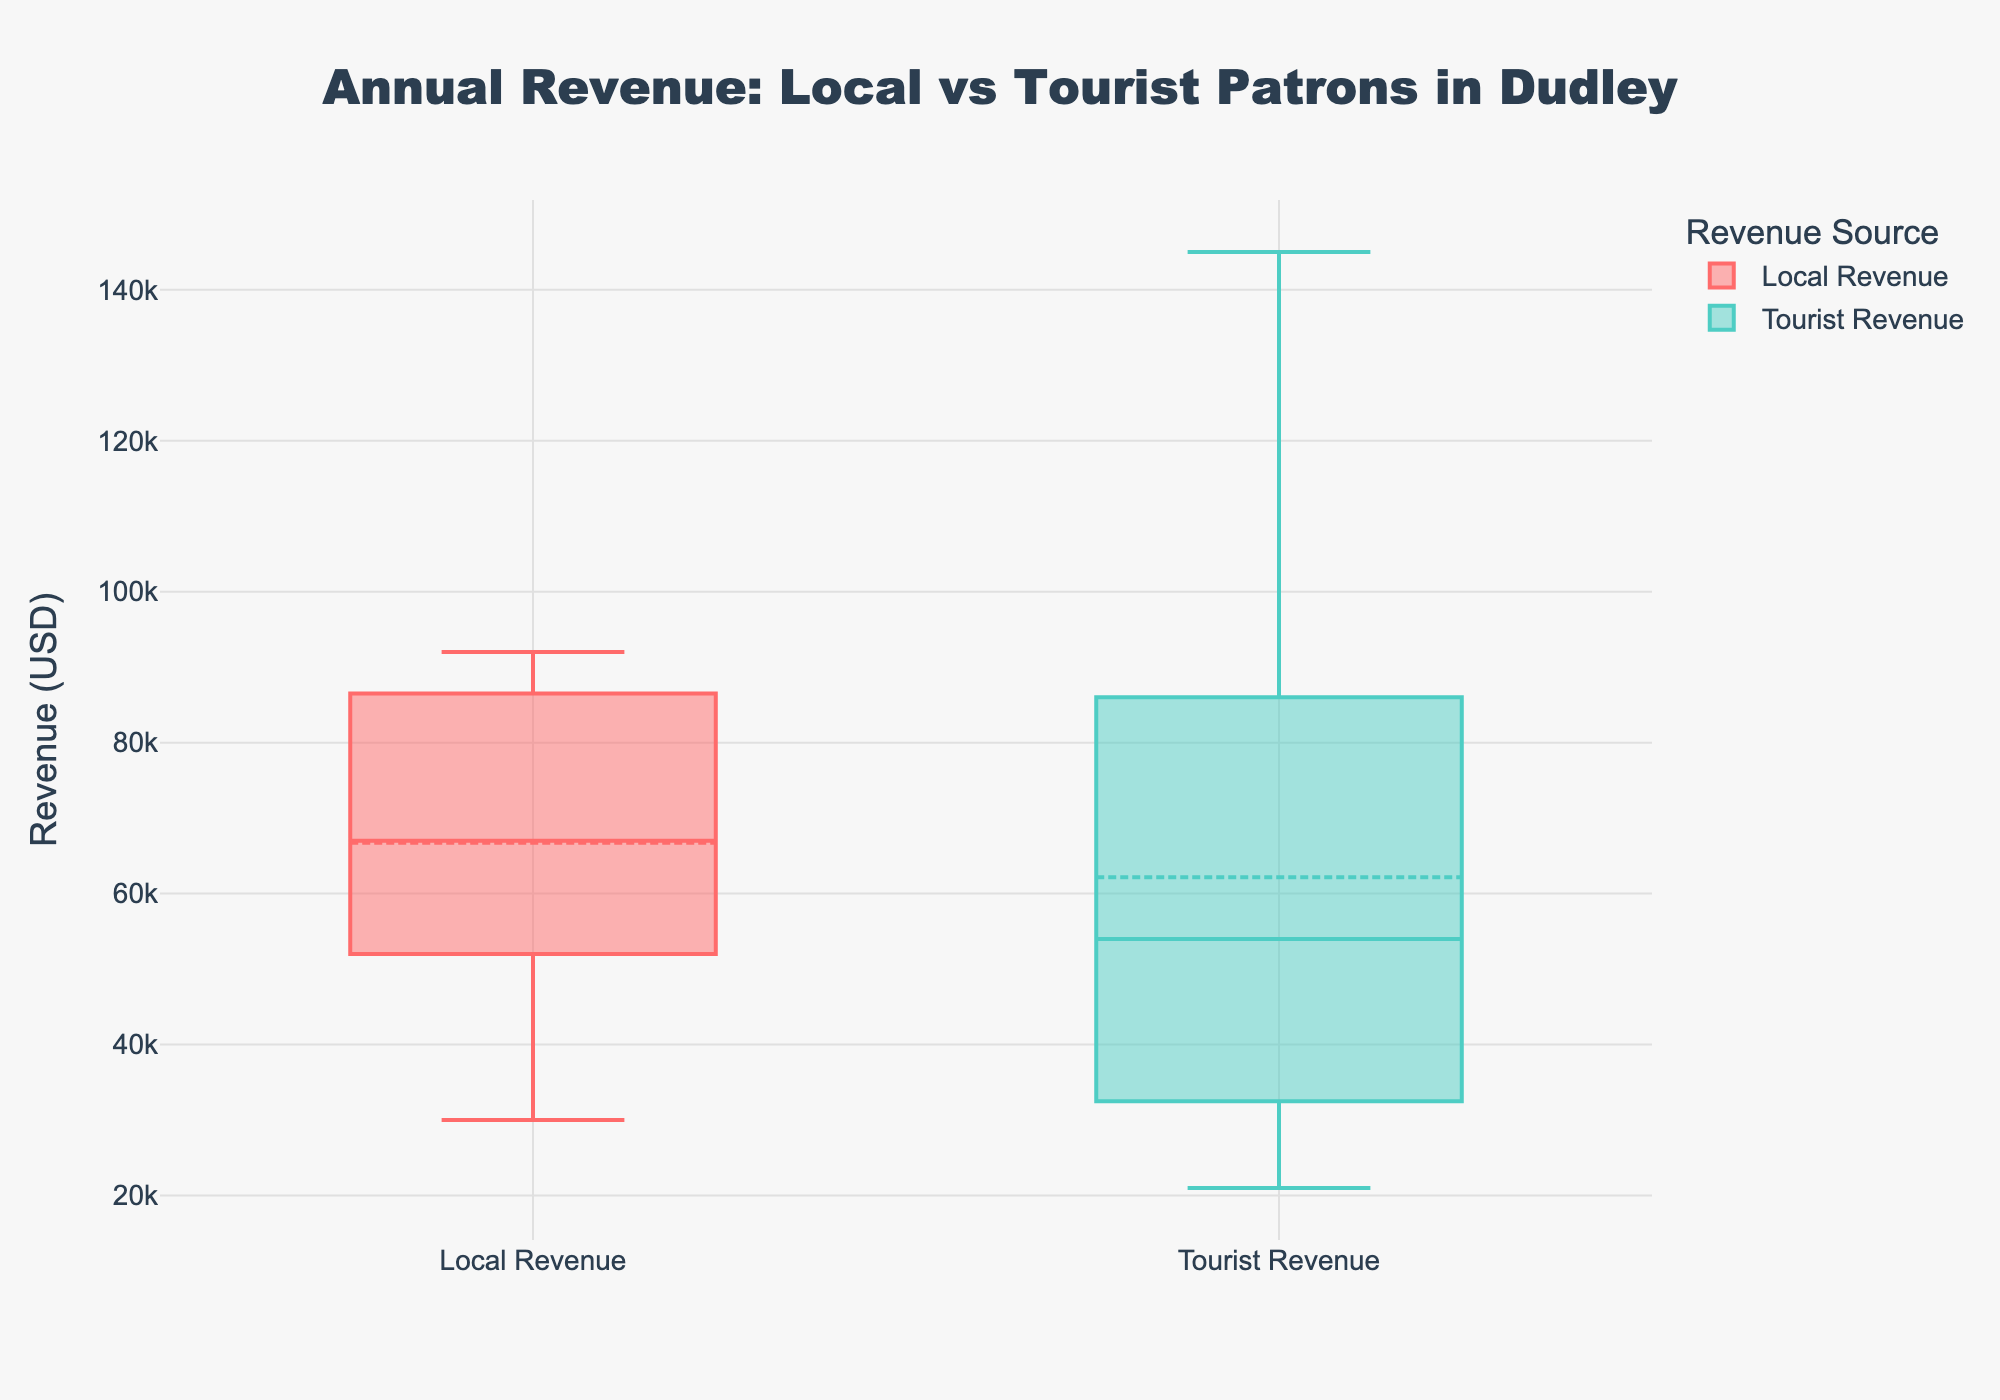which patron type, local or tourist, generates higher median revenue? The plot features box plots, and the median is indicated by a line inside the box. By comparing these lines, the median revenue from tourists appears higher than that from locals.
Answer: Tourist revenue what is the total number of business categories shown in the plot? The plot likely shows box plots for two revenue categories: Local and Tourist Revenue. The data and question context mention two groups, so the total number of business categories is two.
Answer: Two what's the interquartile range (IQR) for local revenue? The Interquartile Range (IQR) is the spread between the 25th percentile (bottom of the box) and the 75th percentile (top of the box) in a box plot. Observing the local revenue box plot, the lower quartile looks to be around 52,000 USD, and the upper quartile is about 87,000 USD. Hence, the IQR is 87,000 - 52,000 = 35,000 USD.
Answer: 35,000 USD how does tourist revenue variability compare to local revenue variability? Variability can be judged by the length of the boxes and the whiskers in the box plot. The tourist revenue box plot shows a greater spread (longer whiskers and box) compared to the local revenue, indicating higher variability for tourist revenue.
Answer: More variable which revenue group has the higher maximum value? The maximum value is shown by the highest whisker or point in each box plot. The tourist revenue group's whisker reaches higher than the local revenue group's, indicating that the tourist revenue group has the higher maximum value.
Answer: Tourist revenue what is the median revenue from local patrons? The median is represented by the line inside the local revenue box plot. Observing this line, it appears to be approximately 67,000 USD.
Answer: 67,000 USD are there any outliers in the tourist revenue group? Outliers in a box plot are often represented by dots outside the whiskers. Observing the tourist revenue box plot, no dots are evident, indicating there are no outliers in the tourist revenue group.
Answer: No compare the mean revenue between local and tourist groups. which is higher? The mean is indicated by a small symbol, usually a diamond or circle, on the box plot. Observing these markers, the mean revenue appears higher in the tourist revenue group compared to the local revenue group.
Answer: Tourist revenue what's the difference between the highest and lowest values in the local revenue group? The highest value is the top of the upper whisker, and the lowest value is the bottom of the lower whisker in the local revenue box plot. Estimating from the plot, the highest is about 91,000 USD and the lowest is around 30,000 USD. Therefore, the difference is 91,000 - 30,000 = 61,000 USD.
Answer: 61,000 USD do tourist or local patrons have a higher median revenue in independent businesses in dudley? Observing the median lines in both box plots, the tourist revenue median is higher than the local revenue median.
Answer: Tourist patrons 